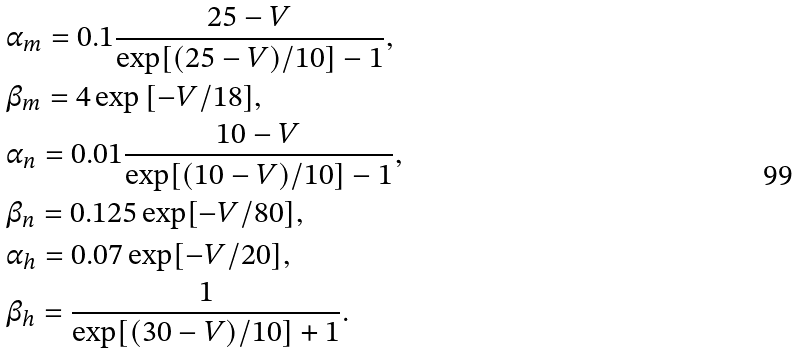Convert formula to latex. <formula><loc_0><loc_0><loc_500><loc_500>& \alpha _ { m } = 0 . 1 \frac { 2 5 - V } { \exp [ ( 2 5 - V ) / 1 0 ] - 1 } , \\ & \beta _ { m } = 4 \exp { [ - V / 1 8 ] } , \\ & \alpha _ { n } = 0 . 0 1 \frac { 1 0 - V } { \exp [ ( 1 0 - V ) / 1 0 ] - 1 } , \\ & \beta _ { n } = 0 . 1 2 5 \exp [ - V / 8 0 ] , \\ & \alpha _ { h } = 0 . 0 7 \exp [ - V / 2 0 ] , \\ & \beta _ { h } = \frac { 1 } { \exp [ ( 3 0 - V ) / 1 0 ] + 1 } .</formula> 